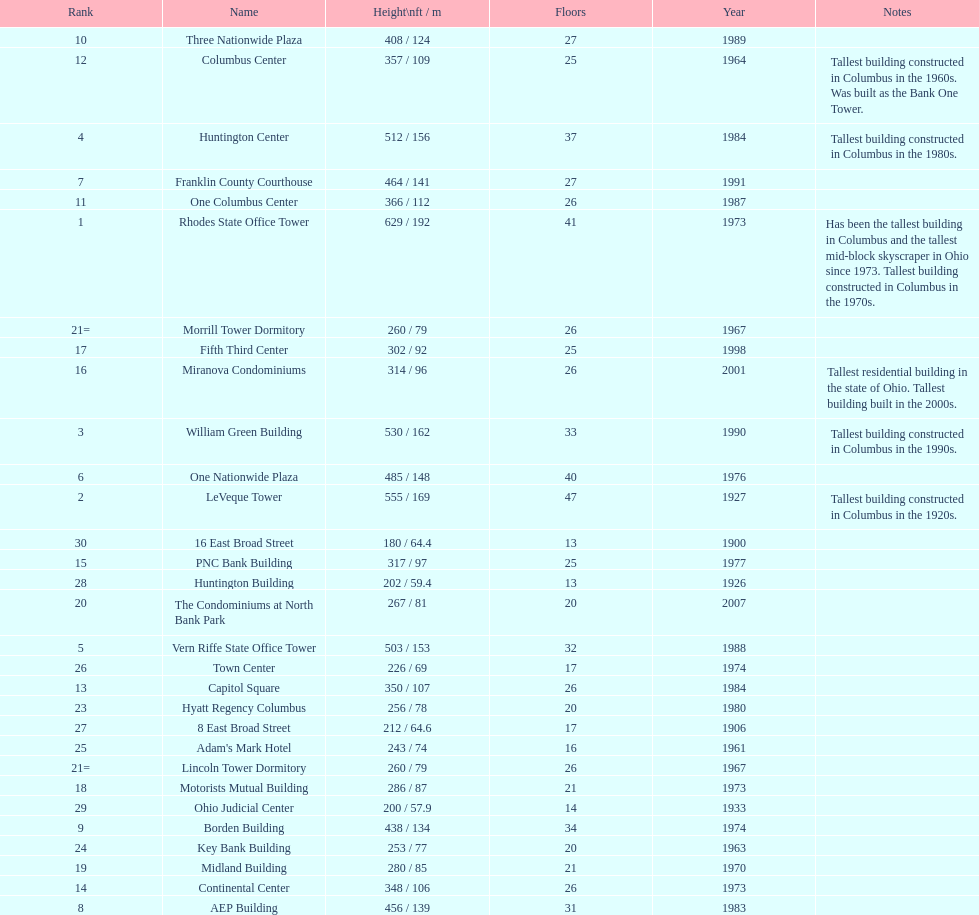Which buildings are taller than 500 ft? Rhodes State Office Tower, LeVeque Tower, William Green Building, Huntington Center, Vern Riffe State Office Tower. 